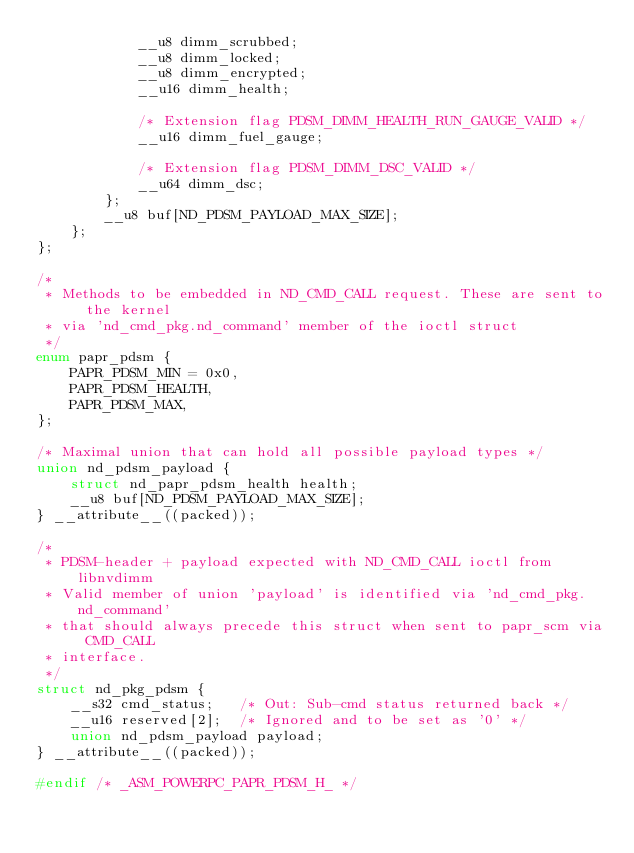<code> <loc_0><loc_0><loc_500><loc_500><_C_>			__u8 dimm_scrubbed;
			__u8 dimm_locked;
			__u8 dimm_encrypted;
			__u16 dimm_health;

			/* Extension flag PDSM_DIMM_HEALTH_RUN_GAUGE_VALID */
			__u16 dimm_fuel_gauge;

			/* Extension flag PDSM_DIMM_DSC_VALID */
			__u64 dimm_dsc;
		};
		__u8 buf[ND_PDSM_PAYLOAD_MAX_SIZE];
	};
};

/*
 * Methods to be embedded in ND_CMD_CALL request. These are sent to the kernel
 * via 'nd_cmd_pkg.nd_command' member of the ioctl struct
 */
enum papr_pdsm {
	PAPR_PDSM_MIN = 0x0,
	PAPR_PDSM_HEALTH,
	PAPR_PDSM_MAX,
};

/* Maximal union that can hold all possible payload types */
union nd_pdsm_payload {
	struct nd_papr_pdsm_health health;
	__u8 buf[ND_PDSM_PAYLOAD_MAX_SIZE];
} __attribute__((packed));

/*
 * PDSM-header + payload expected with ND_CMD_CALL ioctl from libnvdimm
 * Valid member of union 'payload' is identified via 'nd_cmd_pkg.nd_command'
 * that should always precede this struct when sent to papr_scm via CMD_CALL
 * interface.
 */
struct nd_pkg_pdsm {
	__s32 cmd_status;	/* Out: Sub-cmd status returned back */
	__u16 reserved[2];	/* Ignored and to be set as '0' */
	union nd_pdsm_payload payload;
} __attribute__((packed));

#endif /* _ASM_POWERPC_PAPR_PDSM_H_ */</code> 